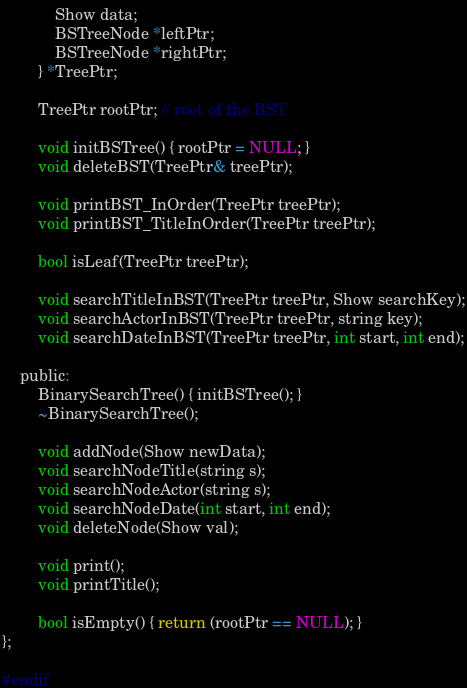<code> <loc_0><loc_0><loc_500><loc_500><_C_>			Show data;
			BSTreeNode *leftPtr;
			BSTreeNode *rightPtr;
		} *TreePtr;

		TreePtr rootPtr; // root of the BST

		void initBSTree() { rootPtr = NULL; }
		void deleteBST(TreePtr& treePtr);

		void printBST_InOrder(TreePtr treePtr);
		void printBST_TitleInOrder(TreePtr treePtr);

		bool isLeaf(TreePtr treePtr);

		void searchTitleInBST(TreePtr treePtr, Show searchKey);
		void searchActorInBST(TreePtr treePtr, string key);
		void searchDateInBST(TreePtr treePtr, int start, int end);

	public:
		BinarySearchTree() { initBSTree(); }
		~BinarySearchTree();

		void addNode(Show newData);
		void searchNodeTitle(string s);
		void searchNodeActor(string s);
		void searchNodeDate(int start, int end);
		void deleteNode(Show val);

		void print();
		void printTitle();

		bool isEmpty() { return (rootPtr == NULL); }
};

#endif
</code> 